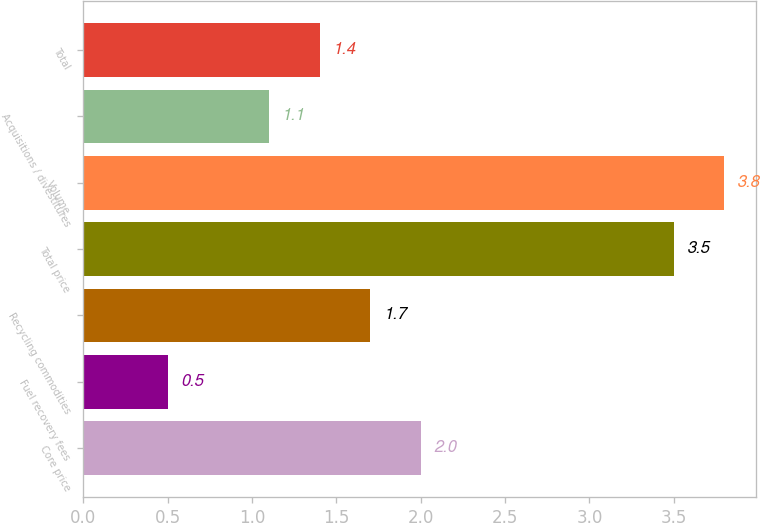Convert chart to OTSL. <chart><loc_0><loc_0><loc_500><loc_500><bar_chart><fcel>Core price<fcel>Fuel recovery fees<fcel>Recycling commodities<fcel>Total price<fcel>Volume<fcel>Acquisitions / divestitures<fcel>Total<nl><fcel>2<fcel>0.5<fcel>1.7<fcel>3.5<fcel>3.8<fcel>1.1<fcel>1.4<nl></chart> 